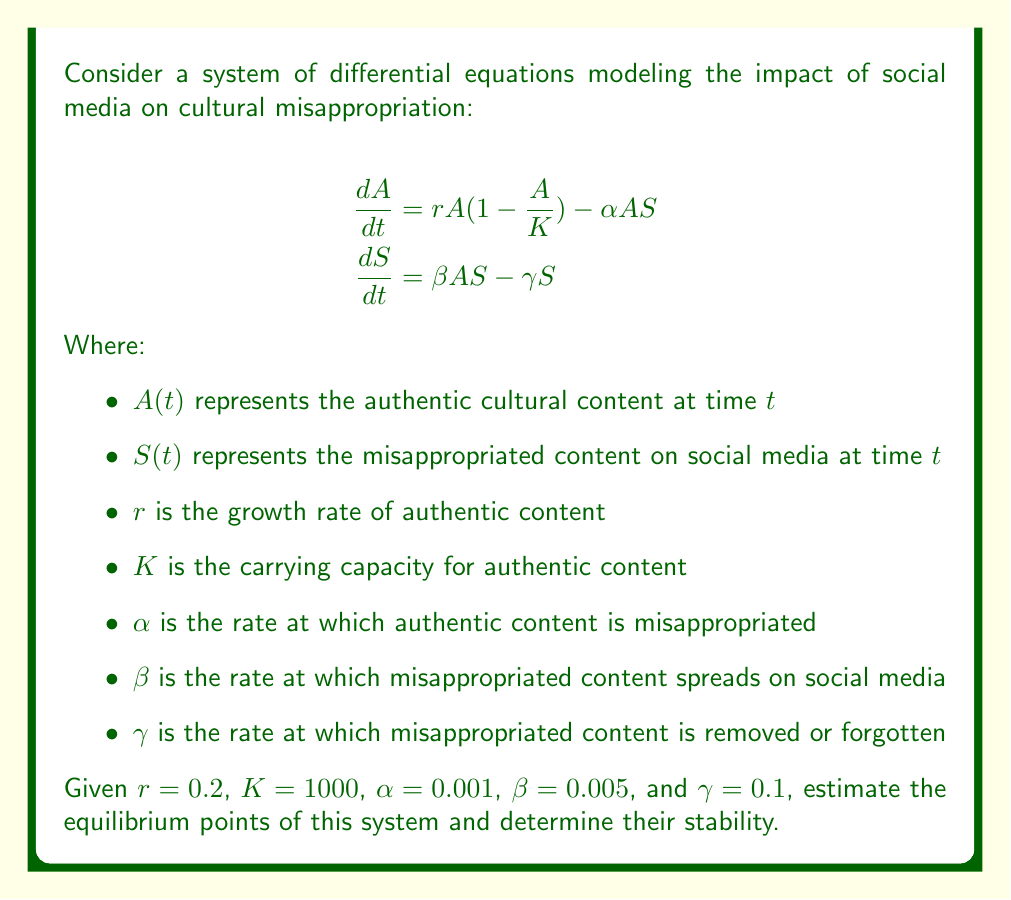Could you help me with this problem? To solve this problem, we'll follow these steps:

1. Find the equilibrium points by setting the derivatives to zero.
2. Analyze the stability of each equilibrium point using the Jacobian matrix.

Step 1: Finding equilibrium points

Set both derivatives to zero:

$$\begin{aligned}
0 &= rA(1-\frac{A}{K}) - \alpha AS \\
0 &= \beta AS - \gamma S
\end{aligned}$$

From the second equation, we have either $S=0$ or $\beta A - \gamma = 0$.

Case 1: If $S=0$, then from the first equation:
$$0 = rA(1-\frac{A}{K})$$
This gives us $A=0$ or $A=K$. So we have two equilibrium points: $(0,0)$ and $(K,0) = (1000,0)$.

Case 2: If $\beta A - \gamma = 0$, then $A = \frac{\gamma}{\beta} = \frac{0.1}{0.005} = 20$.
Substituting this into the first equation:

$$\begin{aligned}
0 &= r\cdot20(1-\frac{20}{K}) - \alpha \cdot20S \\
0 &= 4(0.98) - 0.02S \\
S &= 196
\end{aligned}$$

So our third equilibrium point is $(20,196)$.

Step 2: Analyzing stability

The Jacobian matrix for this system is:

$$J = \begin{bmatrix}
r(1-\frac{2A}{K}) - \alpha S & -\alpha A \\
\beta S & \beta A - \gamma
\end{bmatrix}$$

For $(0,0)$:
$$J_{(0,0)} = \begin{bmatrix}
r & 0 \\
0 & -\gamma
\end{bmatrix}$$

The eigenvalues are $r=0.2$ and $-\gamma=-0.1$. Since one is positive, this is an unstable equilibrium.

For $(1000,0)$:
$$J_{(1000,0)} = \begin{bmatrix}
-r & -\alpha K \\
0 & \beta K - \gamma
\end{bmatrix}$$

The eigenvalues are $-r=-0.2$ and $\beta K - \gamma = 4.9$. Since one is positive, this is also an unstable equilibrium.

For $(20,196)$:
$$J_{(20,196)} = \begin{bmatrix}
-0.184 & -0.02 \\
0.98 & 0
\end{bmatrix}$$

The eigenvalues are approximately $-0.092 \pm 0.135i$. Since both have negative real parts, this is a stable equilibrium.
Answer: The system has three equilibrium points: $(0,0)$, $(1000,0)$, and $(20,196)$. The first two are unstable, while the third is stable. 